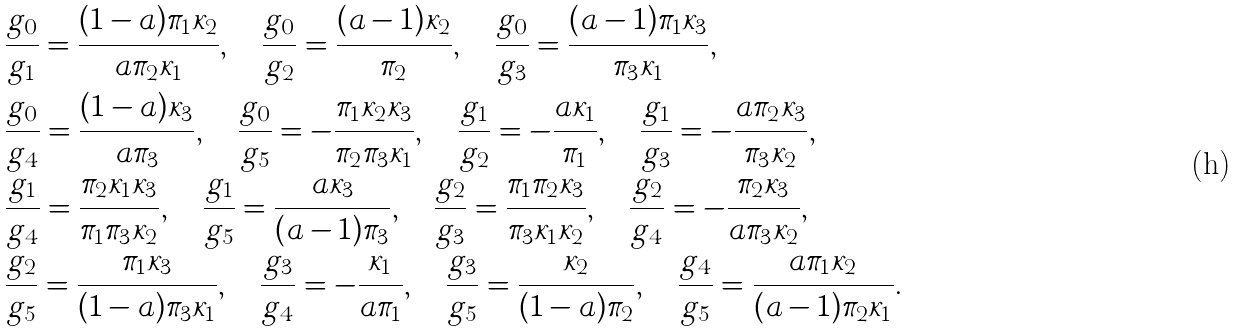<formula> <loc_0><loc_0><loc_500><loc_500>& \frac { g _ { 0 } } { g _ { 1 } } = \frac { ( 1 - a ) \pi _ { 1 } \kappa _ { 2 } } { a \pi _ { 2 } \kappa _ { 1 } } , \quad \frac { g _ { 0 } } { g _ { 2 } } = \frac { ( a - 1 ) \kappa _ { 2 } } { \pi _ { 2 } } , \quad \frac { g _ { 0 } } { g _ { 3 } } = \frac { ( a - 1 ) \pi _ { 1 } \kappa _ { 3 } } { \pi _ { 3 } \kappa _ { 1 } } , \\ & \frac { g _ { 0 } } { g _ { 4 } } = \frac { ( 1 - a ) \kappa _ { 3 } } { a \pi _ { 3 } } , \quad \frac { g _ { 0 } } { g _ { 5 } } = - \frac { \pi _ { 1 } \kappa _ { 2 } \kappa _ { 3 } } { \pi _ { 2 } \pi _ { 3 } \kappa _ { 1 } } , \quad \frac { g _ { 1 } } { g _ { 2 } } = - \frac { a \kappa _ { 1 } } { \pi _ { 1 } } , \quad \frac { g _ { 1 } } { g _ { 3 } } = - \frac { a \pi _ { 2 } \kappa _ { 3 } } { \pi _ { 3 } \kappa _ { 2 } } , \\ & \frac { g _ { 1 } } { g _ { 4 } } = \frac { \pi _ { 2 } \kappa _ { 1 } \kappa _ { 3 } } { \pi _ { 1 } \pi _ { 3 } \kappa _ { 2 } } , \quad \frac { g _ { 1 } } { g _ { 5 } } = \frac { a \kappa _ { 3 } } { ( a - 1 ) \pi _ { 3 } } , \quad \frac { g _ { 2 } } { g _ { 3 } } = \frac { \pi _ { 1 } \pi _ { 2 } \kappa _ { 3 } } { \pi _ { 3 } \kappa _ { 1 } \kappa _ { 2 } } , \quad \frac { g _ { 2 } } { g _ { 4 } } = - \frac { \pi _ { 2 } \kappa _ { 3 } } { a \pi _ { 3 } \kappa _ { 2 } } , \\ & \frac { g _ { 2 } } { g _ { 5 } } = \frac { \pi _ { 1 } \kappa _ { 3 } } { ( 1 - a ) \pi _ { 3 } \kappa _ { 1 } } , \quad \frac { g _ { 3 } } { g _ { 4 } } = - \frac { \kappa _ { 1 } } { a \pi _ { 1 } } , \quad \frac { g _ { 3 } } { g _ { 5 } } = \frac { \kappa _ { 2 } } { ( 1 - a ) \pi _ { 2 } } , \quad \frac { g _ { 4 } } { g _ { 5 } } = \frac { a \pi _ { 1 } \kappa _ { 2 } } { ( a - 1 ) \pi _ { 2 } \kappa _ { 1 } } .</formula> 